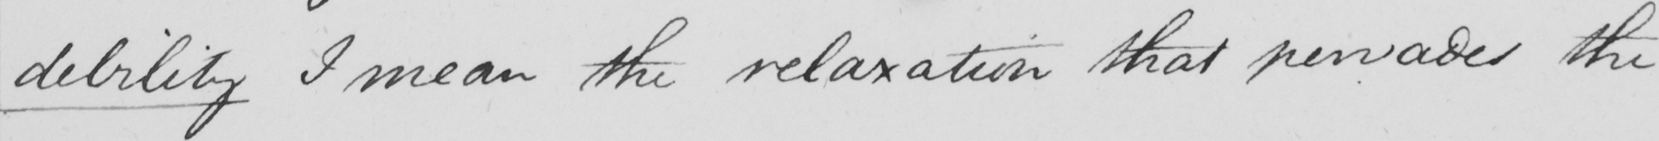Please provide the text content of this handwritten line. debility I mean the relaxation that pervades the 